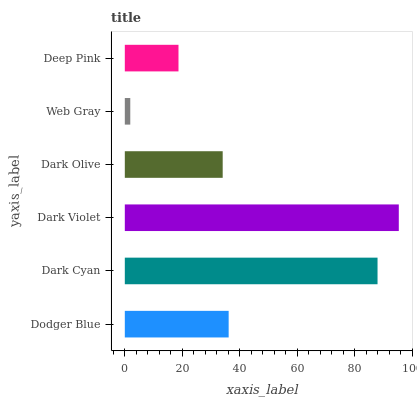Is Web Gray the minimum?
Answer yes or no. Yes. Is Dark Violet the maximum?
Answer yes or no. Yes. Is Dark Cyan the minimum?
Answer yes or no. No. Is Dark Cyan the maximum?
Answer yes or no. No. Is Dark Cyan greater than Dodger Blue?
Answer yes or no. Yes. Is Dodger Blue less than Dark Cyan?
Answer yes or no. Yes. Is Dodger Blue greater than Dark Cyan?
Answer yes or no. No. Is Dark Cyan less than Dodger Blue?
Answer yes or no. No. Is Dodger Blue the high median?
Answer yes or no. Yes. Is Dark Olive the low median?
Answer yes or no. Yes. Is Dark Olive the high median?
Answer yes or no. No. Is Dark Violet the low median?
Answer yes or no. No. 